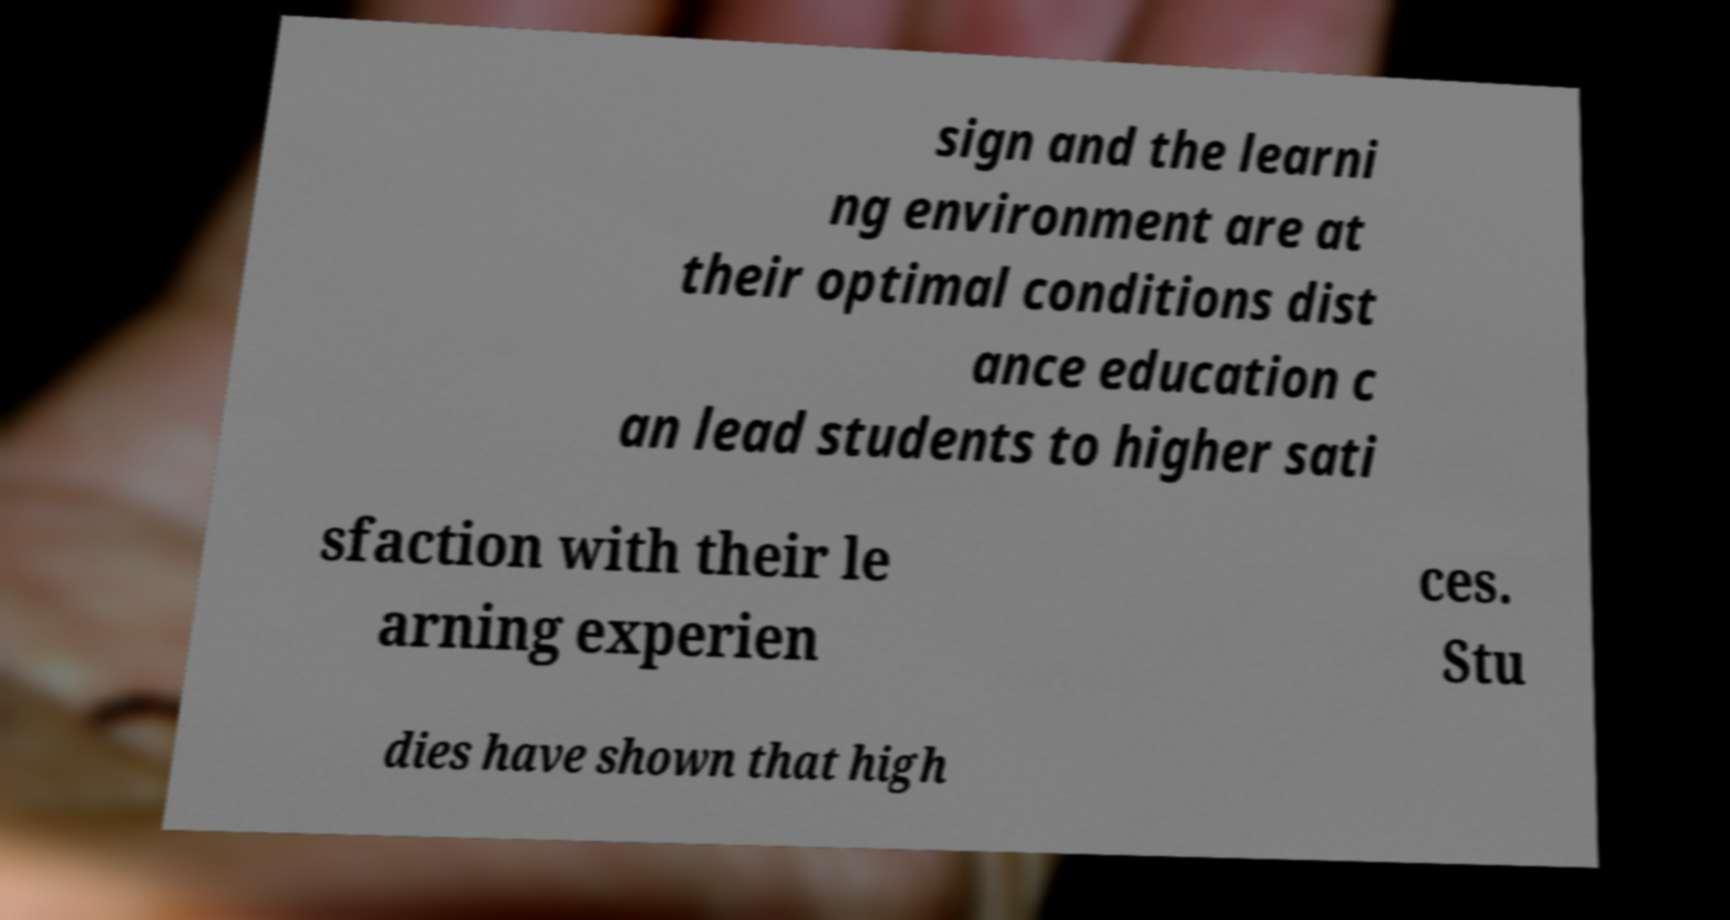Could you assist in decoding the text presented in this image and type it out clearly? sign and the learni ng environment are at their optimal conditions dist ance education c an lead students to higher sati sfaction with their le arning experien ces. Stu dies have shown that high 